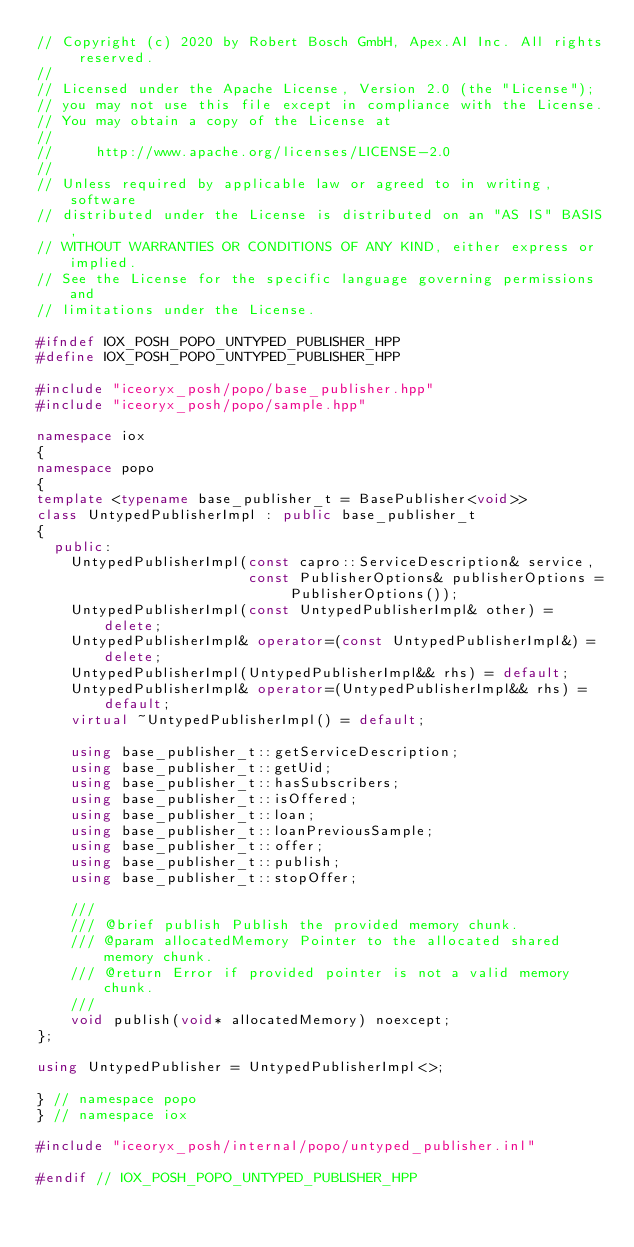Convert code to text. <code><loc_0><loc_0><loc_500><loc_500><_C++_>// Copyright (c) 2020 by Robert Bosch GmbH, Apex.AI Inc. All rights reserved.
//
// Licensed under the Apache License, Version 2.0 (the "License");
// you may not use this file except in compliance with the License.
// You may obtain a copy of the License at
//
//     http://www.apache.org/licenses/LICENSE-2.0
//
// Unless required by applicable law or agreed to in writing, software
// distributed under the License is distributed on an "AS IS" BASIS,
// WITHOUT WARRANTIES OR CONDITIONS OF ANY KIND, either express or implied.
// See the License for the specific language governing permissions and
// limitations under the License.

#ifndef IOX_POSH_POPO_UNTYPED_PUBLISHER_HPP
#define IOX_POSH_POPO_UNTYPED_PUBLISHER_HPP

#include "iceoryx_posh/popo/base_publisher.hpp"
#include "iceoryx_posh/popo/sample.hpp"

namespace iox
{
namespace popo
{
template <typename base_publisher_t = BasePublisher<void>>
class UntypedPublisherImpl : public base_publisher_t
{
  public:
    UntypedPublisherImpl(const capro::ServiceDescription& service,
                         const PublisherOptions& publisherOptions = PublisherOptions());
    UntypedPublisherImpl(const UntypedPublisherImpl& other) = delete;
    UntypedPublisherImpl& operator=(const UntypedPublisherImpl&) = delete;
    UntypedPublisherImpl(UntypedPublisherImpl&& rhs) = default;
    UntypedPublisherImpl& operator=(UntypedPublisherImpl&& rhs) = default;
    virtual ~UntypedPublisherImpl() = default;

    using base_publisher_t::getServiceDescription;
    using base_publisher_t::getUid;
    using base_publisher_t::hasSubscribers;
    using base_publisher_t::isOffered;
    using base_publisher_t::loan;
    using base_publisher_t::loanPreviousSample;
    using base_publisher_t::offer;
    using base_publisher_t::publish;
    using base_publisher_t::stopOffer;

    ///
    /// @brief publish Publish the provided memory chunk.
    /// @param allocatedMemory Pointer to the allocated shared memory chunk.
    /// @return Error if provided pointer is not a valid memory chunk.
    ///
    void publish(void* allocatedMemory) noexcept;
};

using UntypedPublisher = UntypedPublisherImpl<>;

} // namespace popo
} // namespace iox

#include "iceoryx_posh/internal/popo/untyped_publisher.inl"

#endif // IOX_POSH_POPO_UNTYPED_PUBLISHER_HPP
</code> 